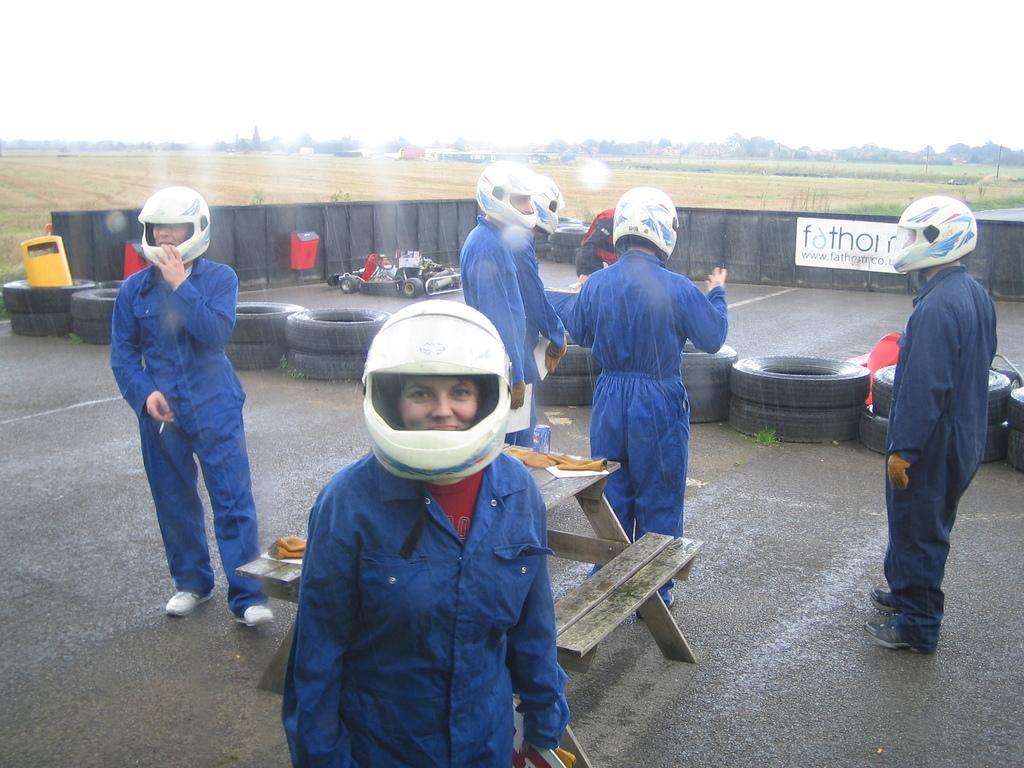How would you summarize this image in a sentence or two? In this picture we see open area and we see four people standing by wearing a uniform and helmet on their head and we can see a bench And a sports car parked on the road. 